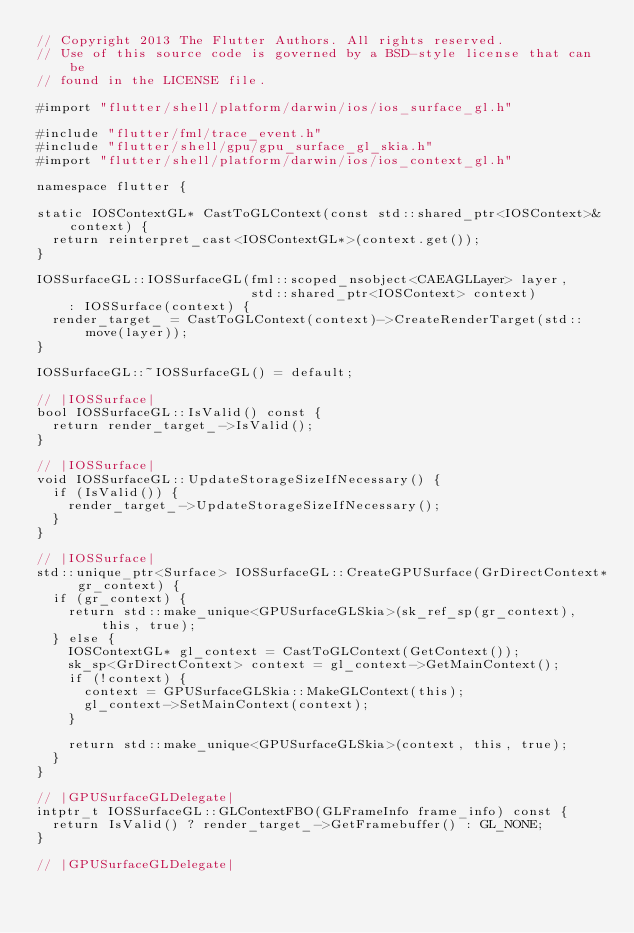Convert code to text. <code><loc_0><loc_0><loc_500><loc_500><_ObjectiveC_>// Copyright 2013 The Flutter Authors. All rights reserved.
// Use of this source code is governed by a BSD-style license that can be
// found in the LICENSE file.

#import "flutter/shell/platform/darwin/ios/ios_surface_gl.h"

#include "flutter/fml/trace_event.h"
#include "flutter/shell/gpu/gpu_surface_gl_skia.h"
#import "flutter/shell/platform/darwin/ios/ios_context_gl.h"

namespace flutter {

static IOSContextGL* CastToGLContext(const std::shared_ptr<IOSContext>& context) {
  return reinterpret_cast<IOSContextGL*>(context.get());
}

IOSSurfaceGL::IOSSurfaceGL(fml::scoped_nsobject<CAEAGLLayer> layer,
                           std::shared_ptr<IOSContext> context)
    : IOSSurface(context) {
  render_target_ = CastToGLContext(context)->CreateRenderTarget(std::move(layer));
}

IOSSurfaceGL::~IOSSurfaceGL() = default;

// |IOSSurface|
bool IOSSurfaceGL::IsValid() const {
  return render_target_->IsValid();
}

// |IOSSurface|
void IOSSurfaceGL::UpdateStorageSizeIfNecessary() {
  if (IsValid()) {
    render_target_->UpdateStorageSizeIfNecessary();
  }
}

// |IOSSurface|
std::unique_ptr<Surface> IOSSurfaceGL::CreateGPUSurface(GrDirectContext* gr_context) {
  if (gr_context) {
    return std::make_unique<GPUSurfaceGLSkia>(sk_ref_sp(gr_context), this, true);
  } else {
    IOSContextGL* gl_context = CastToGLContext(GetContext());
    sk_sp<GrDirectContext> context = gl_context->GetMainContext();
    if (!context) {
      context = GPUSurfaceGLSkia::MakeGLContext(this);
      gl_context->SetMainContext(context);
    }

    return std::make_unique<GPUSurfaceGLSkia>(context, this, true);
  }
}

// |GPUSurfaceGLDelegate|
intptr_t IOSSurfaceGL::GLContextFBO(GLFrameInfo frame_info) const {
  return IsValid() ? render_target_->GetFramebuffer() : GL_NONE;
}

// |GPUSurfaceGLDelegate|</code> 